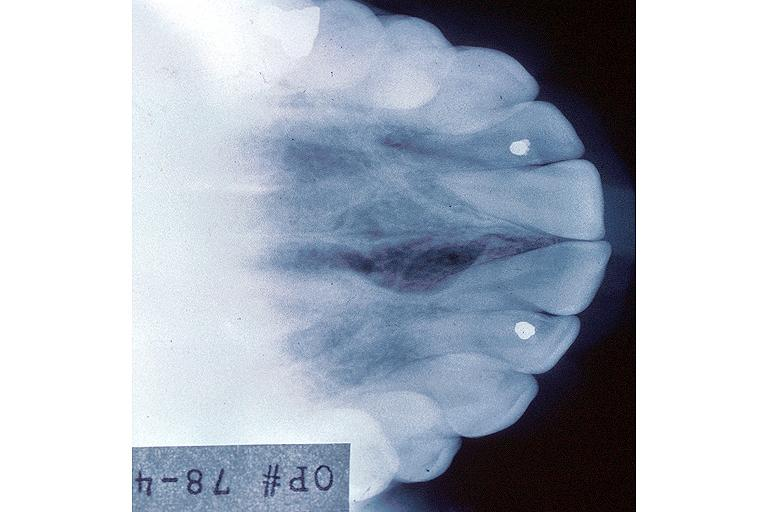where is this?
Answer the question using a single word or phrase. Oral 